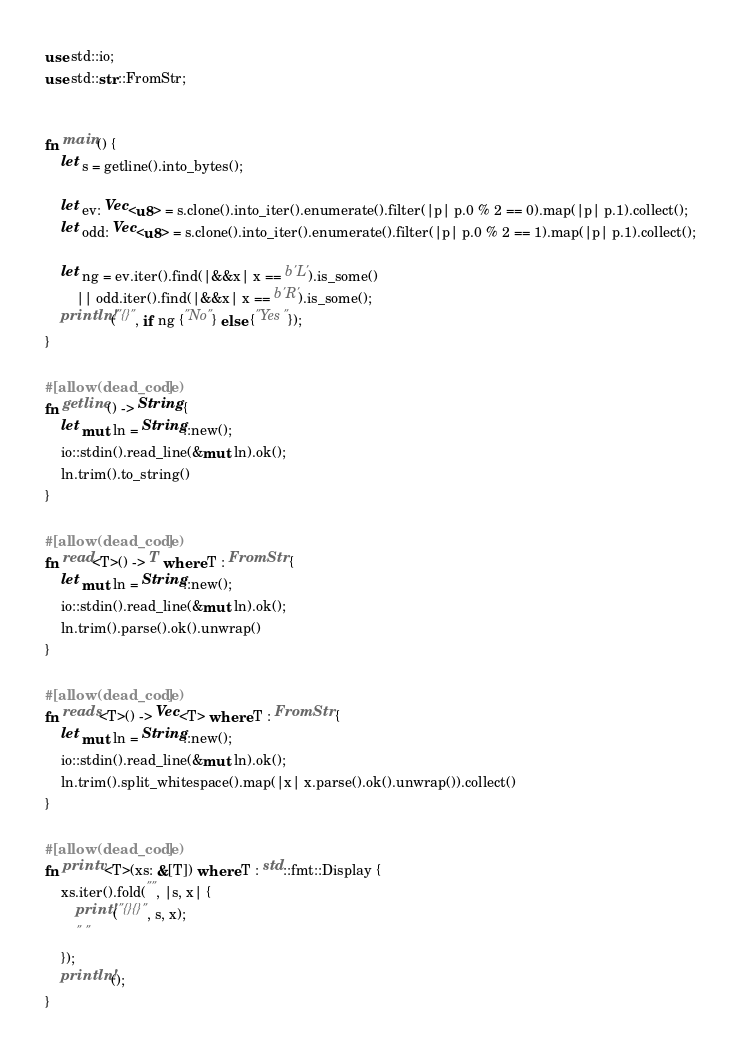Convert code to text. <code><loc_0><loc_0><loc_500><loc_500><_Rust_>use std::io;
use std::str::FromStr;


fn main() {
    let s = getline().into_bytes();

    let ev: Vec<u8> = s.clone().into_iter().enumerate().filter(|p| p.0 % 2 == 0).map(|p| p.1).collect();
    let odd: Vec<u8> = s.clone().into_iter().enumerate().filter(|p| p.0 % 2 == 1).map(|p| p.1).collect();

    let ng = ev.iter().find(|&&x| x == b'L').is_some()
        || odd.iter().find(|&&x| x == b'R').is_some();
    println!("{}", if ng {"No"} else {"Yes"});
}

#[allow(dead_code)]
fn getline() -> String {
    let mut ln = String::new();
    io::stdin().read_line(&mut ln).ok();
    ln.trim().to_string()
}

#[allow(dead_code)]
fn read<T>() -> T where T : FromStr {
    let mut ln = String::new();
    io::stdin().read_line(&mut ln).ok();
    ln.trim().parse().ok().unwrap()
}

#[allow(dead_code)]
fn reads<T>() -> Vec<T> where T : FromStr {
    let mut ln = String::new();
    io::stdin().read_line(&mut ln).ok();
    ln.trim().split_whitespace().map(|x| x.parse().ok().unwrap()).collect()
}

#[allow(dead_code)]
fn printv<T>(xs: &[T]) where T : std::fmt::Display {
    xs.iter().fold("", |s, x| {
        print!("{}{}", s, x);
        " "
    });
    println!();
}
</code> 